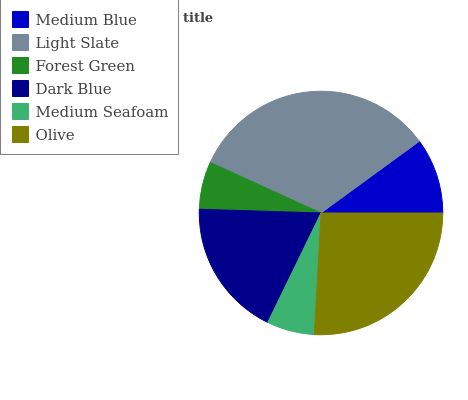Is Forest Green the minimum?
Answer yes or no. Yes. Is Light Slate the maximum?
Answer yes or no. Yes. Is Light Slate the minimum?
Answer yes or no. No. Is Forest Green the maximum?
Answer yes or no. No. Is Light Slate greater than Forest Green?
Answer yes or no. Yes. Is Forest Green less than Light Slate?
Answer yes or no. Yes. Is Forest Green greater than Light Slate?
Answer yes or no. No. Is Light Slate less than Forest Green?
Answer yes or no. No. Is Dark Blue the high median?
Answer yes or no. Yes. Is Medium Blue the low median?
Answer yes or no. Yes. Is Medium Seafoam the high median?
Answer yes or no. No. Is Dark Blue the low median?
Answer yes or no. No. 